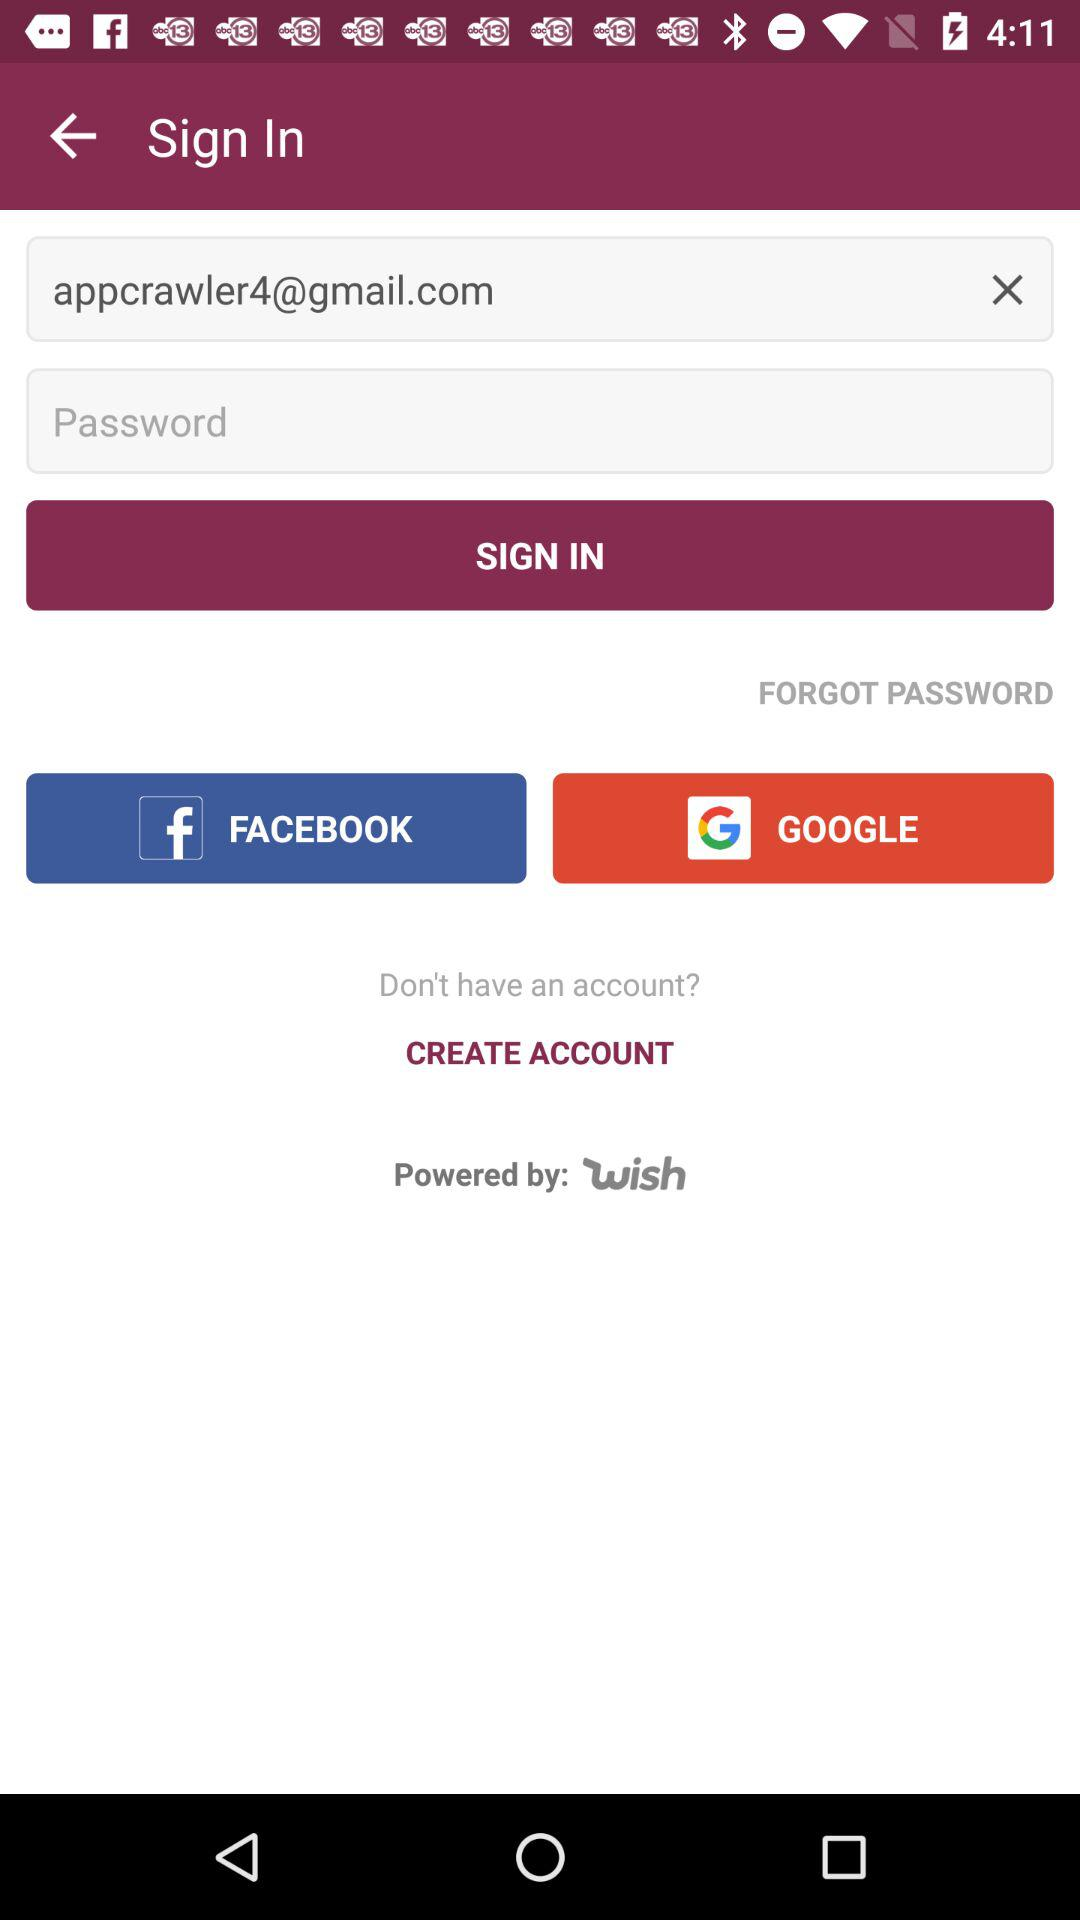What is the email address? The email address is appcrawler4@gmail.com. 